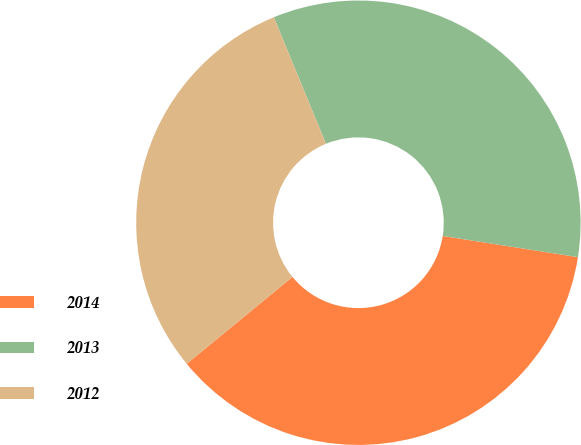<chart> <loc_0><loc_0><loc_500><loc_500><pie_chart><fcel>2014<fcel>2013<fcel>2012<nl><fcel>36.58%<fcel>33.69%<fcel>29.73%<nl></chart> 